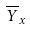<formula> <loc_0><loc_0><loc_500><loc_500>\overline { Y } _ { x }</formula> 